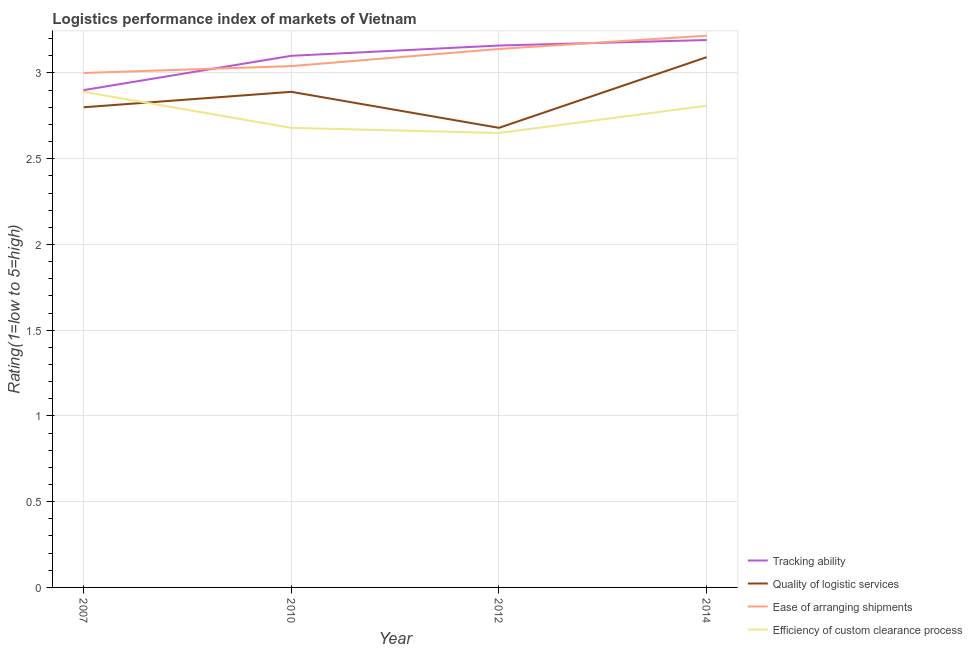What is the lpi rating of tracking ability in 2007?
Provide a succinct answer. 2.9. Across all years, what is the maximum lpi rating of tracking ability?
Offer a very short reply. 3.19. Across all years, what is the minimum lpi rating of quality of logistic services?
Offer a very short reply. 2.68. In which year was the lpi rating of quality of logistic services minimum?
Offer a terse response. 2012. What is the total lpi rating of efficiency of custom clearance process in the graph?
Your answer should be compact. 11.03. What is the difference between the lpi rating of tracking ability in 2012 and that in 2014?
Your response must be concise. -0.03. What is the difference between the lpi rating of efficiency of custom clearance process in 2014 and the lpi rating of tracking ability in 2012?
Provide a succinct answer. -0.35. What is the average lpi rating of quality of logistic services per year?
Your answer should be very brief. 2.87. In the year 2012, what is the difference between the lpi rating of quality of logistic services and lpi rating of ease of arranging shipments?
Ensure brevity in your answer.  -0.46. What is the ratio of the lpi rating of efficiency of custom clearance process in 2010 to that in 2012?
Offer a very short reply. 1.01. Is the lpi rating of efficiency of custom clearance process in 2007 less than that in 2014?
Your response must be concise. No. Is the difference between the lpi rating of tracking ability in 2007 and 2012 greater than the difference between the lpi rating of efficiency of custom clearance process in 2007 and 2012?
Ensure brevity in your answer.  No. What is the difference between the highest and the second highest lpi rating of ease of arranging shipments?
Make the answer very short. 0.08. What is the difference between the highest and the lowest lpi rating of quality of logistic services?
Your response must be concise. 0.41. Is it the case that in every year, the sum of the lpi rating of quality of logistic services and lpi rating of ease of arranging shipments is greater than the sum of lpi rating of efficiency of custom clearance process and lpi rating of tracking ability?
Your answer should be very brief. Yes. Is the lpi rating of tracking ability strictly greater than the lpi rating of efficiency of custom clearance process over the years?
Offer a terse response. Yes. How many years are there in the graph?
Provide a succinct answer. 4. What is the difference between two consecutive major ticks on the Y-axis?
Make the answer very short. 0.5. Are the values on the major ticks of Y-axis written in scientific E-notation?
Provide a short and direct response. No. Does the graph contain any zero values?
Your answer should be compact. No. Does the graph contain grids?
Make the answer very short. Yes. How are the legend labels stacked?
Offer a terse response. Vertical. What is the title of the graph?
Your response must be concise. Logistics performance index of markets of Vietnam. Does "Other expenses" appear as one of the legend labels in the graph?
Your answer should be compact. No. What is the label or title of the X-axis?
Offer a terse response. Year. What is the label or title of the Y-axis?
Make the answer very short. Rating(1=low to 5=high). What is the Rating(1=low to 5=high) of Quality of logistic services in 2007?
Ensure brevity in your answer.  2.8. What is the Rating(1=low to 5=high) of Ease of arranging shipments in 2007?
Provide a short and direct response. 3. What is the Rating(1=low to 5=high) of Efficiency of custom clearance process in 2007?
Your answer should be compact. 2.89. What is the Rating(1=low to 5=high) of Tracking ability in 2010?
Ensure brevity in your answer.  3.1. What is the Rating(1=low to 5=high) in Quality of logistic services in 2010?
Your answer should be compact. 2.89. What is the Rating(1=low to 5=high) in Ease of arranging shipments in 2010?
Keep it short and to the point. 3.04. What is the Rating(1=low to 5=high) of Efficiency of custom clearance process in 2010?
Your answer should be very brief. 2.68. What is the Rating(1=low to 5=high) in Tracking ability in 2012?
Your answer should be very brief. 3.16. What is the Rating(1=low to 5=high) of Quality of logistic services in 2012?
Your answer should be very brief. 2.68. What is the Rating(1=low to 5=high) of Ease of arranging shipments in 2012?
Offer a terse response. 3.14. What is the Rating(1=low to 5=high) of Efficiency of custom clearance process in 2012?
Keep it short and to the point. 2.65. What is the Rating(1=low to 5=high) in Tracking ability in 2014?
Give a very brief answer. 3.19. What is the Rating(1=low to 5=high) in Quality of logistic services in 2014?
Keep it short and to the point. 3.09. What is the Rating(1=low to 5=high) of Ease of arranging shipments in 2014?
Your response must be concise. 3.22. What is the Rating(1=low to 5=high) of Efficiency of custom clearance process in 2014?
Your answer should be compact. 2.81. Across all years, what is the maximum Rating(1=low to 5=high) of Tracking ability?
Offer a very short reply. 3.19. Across all years, what is the maximum Rating(1=low to 5=high) in Quality of logistic services?
Your answer should be very brief. 3.09. Across all years, what is the maximum Rating(1=low to 5=high) in Ease of arranging shipments?
Keep it short and to the point. 3.22. Across all years, what is the maximum Rating(1=low to 5=high) in Efficiency of custom clearance process?
Make the answer very short. 2.89. Across all years, what is the minimum Rating(1=low to 5=high) in Quality of logistic services?
Ensure brevity in your answer.  2.68. Across all years, what is the minimum Rating(1=low to 5=high) of Efficiency of custom clearance process?
Offer a terse response. 2.65. What is the total Rating(1=low to 5=high) in Tracking ability in the graph?
Make the answer very short. 12.35. What is the total Rating(1=low to 5=high) of Quality of logistic services in the graph?
Give a very brief answer. 11.46. What is the total Rating(1=low to 5=high) of Ease of arranging shipments in the graph?
Your response must be concise. 12.4. What is the total Rating(1=low to 5=high) of Efficiency of custom clearance process in the graph?
Your answer should be very brief. 11.03. What is the difference between the Rating(1=low to 5=high) of Quality of logistic services in 2007 and that in 2010?
Your response must be concise. -0.09. What is the difference between the Rating(1=low to 5=high) of Ease of arranging shipments in 2007 and that in 2010?
Ensure brevity in your answer.  -0.04. What is the difference between the Rating(1=low to 5=high) in Efficiency of custom clearance process in 2007 and that in 2010?
Provide a succinct answer. 0.21. What is the difference between the Rating(1=low to 5=high) in Tracking ability in 2007 and that in 2012?
Your answer should be compact. -0.26. What is the difference between the Rating(1=low to 5=high) in Quality of logistic services in 2007 and that in 2012?
Provide a succinct answer. 0.12. What is the difference between the Rating(1=low to 5=high) of Ease of arranging shipments in 2007 and that in 2012?
Offer a very short reply. -0.14. What is the difference between the Rating(1=low to 5=high) of Efficiency of custom clearance process in 2007 and that in 2012?
Keep it short and to the point. 0.24. What is the difference between the Rating(1=low to 5=high) in Tracking ability in 2007 and that in 2014?
Offer a terse response. -0.29. What is the difference between the Rating(1=low to 5=high) in Quality of logistic services in 2007 and that in 2014?
Offer a terse response. -0.29. What is the difference between the Rating(1=low to 5=high) in Ease of arranging shipments in 2007 and that in 2014?
Offer a terse response. -0.22. What is the difference between the Rating(1=low to 5=high) of Efficiency of custom clearance process in 2007 and that in 2014?
Your response must be concise. 0.08. What is the difference between the Rating(1=low to 5=high) in Tracking ability in 2010 and that in 2012?
Give a very brief answer. -0.06. What is the difference between the Rating(1=low to 5=high) in Quality of logistic services in 2010 and that in 2012?
Make the answer very short. 0.21. What is the difference between the Rating(1=low to 5=high) of Tracking ability in 2010 and that in 2014?
Keep it short and to the point. -0.09. What is the difference between the Rating(1=low to 5=high) in Quality of logistic services in 2010 and that in 2014?
Provide a succinct answer. -0.2. What is the difference between the Rating(1=low to 5=high) in Ease of arranging shipments in 2010 and that in 2014?
Give a very brief answer. -0.18. What is the difference between the Rating(1=low to 5=high) of Efficiency of custom clearance process in 2010 and that in 2014?
Make the answer very short. -0.13. What is the difference between the Rating(1=low to 5=high) in Tracking ability in 2012 and that in 2014?
Your response must be concise. -0.03. What is the difference between the Rating(1=low to 5=high) of Quality of logistic services in 2012 and that in 2014?
Your answer should be very brief. -0.41. What is the difference between the Rating(1=low to 5=high) of Ease of arranging shipments in 2012 and that in 2014?
Give a very brief answer. -0.08. What is the difference between the Rating(1=low to 5=high) of Efficiency of custom clearance process in 2012 and that in 2014?
Your answer should be compact. -0.16. What is the difference between the Rating(1=low to 5=high) in Tracking ability in 2007 and the Rating(1=low to 5=high) in Ease of arranging shipments in 2010?
Make the answer very short. -0.14. What is the difference between the Rating(1=low to 5=high) in Tracking ability in 2007 and the Rating(1=low to 5=high) in Efficiency of custom clearance process in 2010?
Keep it short and to the point. 0.22. What is the difference between the Rating(1=low to 5=high) in Quality of logistic services in 2007 and the Rating(1=low to 5=high) in Ease of arranging shipments in 2010?
Provide a succinct answer. -0.24. What is the difference between the Rating(1=low to 5=high) in Quality of logistic services in 2007 and the Rating(1=low to 5=high) in Efficiency of custom clearance process in 2010?
Provide a short and direct response. 0.12. What is the difference between the Rating(1=low to 5=high) of Ease of arranging shipments in 2007 and the Rating(1=low to 5=high) of Efficiency of custom clearance process in 2010?
Give a very brief answer. 0.32. What is the difference between the Rating(1=low to 5=high) in Tracking ability in 2007 and the Rating(1=low to 5=high) in Quality of logistic services in 2012?
Your answer should be compact. 0.22. What is the difference between the Rating(1=low to 5=high) of Tracking ability in 2007 and the Rating(1=low to 5=high) of Ease of arranging shipments in 2012?
Your answer should be very brief. -0.24. What is the difference between the Rating(1=low to 5=high) in Quality of logistic services in 2007 and the Rating(1=low to 5=high) in Ease of arranging shipments in 2012?
Keep it short and to the point. -0.34. What is the difference between the Rating(1=low to 5=high) of Ease of arranging shipments in 2007 and the Rating(1=low to 5=high) of Efficiency of custom clearance process in 2012?
Provide a short and direct response. 0.35. What is the difference between the Rating(1=low to 5=high) of Tracking ability in 2007 and the Rating(1=low to 5=high) of Quality of logistic services in 2014?
Make the answer very short. -0.19. What is the difference between the Rating(1=low to 5=high) in Tracking ability in 2007 and the Rating(1=low to 5=high) in Ease of arranging shipments in 2014?
Your answer should be compact. -0.32. What is the difference between the Rating(1=low to 5=high) of Tracking ability in 2007 and the Rating(1=low to 5=high) of Efficiency of custom clearance process in 2014?
Your answer should be very brief. 0.09. What is the difference between the Rating(1=low to 5=high) of Quality of logistic services in 2007 and the Rating(1=low to 5=high) of Ease of arranging shipments in 2014?
Give a very brief answer. -0.42. What is the difference between the Rating(1=low to 5=high) of Quality of logistic services in 2007 and the Rating(1=low to 5=high) of Efficiency of custom clearance process in 2014?
Offer a terse response. -0.01. What is the difference between the Rating(1=low to 5=high) of Ease of arranging shipments in 2007 and the Rating(1=low to 5=high) of Efficiency of custom clearance process in 2014?
Your response must be concise. 0.19. What is the difference between the Rating(1=low to 5=high) in Tracking ability in 2010 and the Rating(1=low to 5=high) in Quality of logistic services in 2012?
Your answer should be compact. 0.42. What is the difference between the Rating(1=low to 5=high) in Tracking ability in 2010 and the Rating(1=low to 5=high) in Ease of arranging shipments in 2012?
Your response must be concise. -0.04. What is the difference between the Rating(1=low to 5=high) of Tracking ability in 2010 and the Rating(1=low to 5=high) of Efficiency of custom clearance process in 2012?
Give a very brief answer. 0.45. What is the difference between the Rating(1=low to 5=high) in Quality of logistic services in 2010 and the Rating(1=low to 5=high) in Ease of arranging shipments in 2012?
Your answer should be very brief. -0.25. What is the difference between the Rating(1=low to 5=high) in Quality of logistic services in 2010 and the Rating(1=low to 5=high) in Efficiency of custom clearance process in 2012?
Offer a very short reply. 0.24. What is the difference between the Rating(1=low to 5=high) of Ease of arranging shipments in 2010 and the Rating(1=low to 5=high) of Efficiency of custom clearance process in 2012?
Provide a short and direct response. 0.39. What is the difference between the Rating(1=low to 5=high) in Tracking ability in 2010 and the Rating(1=low to 5=high) in Quality of logistic services in 2014?
Your answer should be very brief. 0.01. What is the difference between the Rating(1=low to 5=high) of Tracking ability in 2010 and the Rating(1=low to 5=high) of Ease of arranging shipments in 2014?
Make the answer very short. -0.12. What is the difference between the Rating(1=low to 5=high) in Tracking ability in 2010 and the Rating(1=low to 5=high) in Efficiency of custom clearance process in 2014?
Offer a terse response. 0.29. What is the difference between the Rating(1=low to 5=high) of Quality of logistic services in 2010 and the Rating(1=low to 5=high) of Ease of arranging shipments in 2014?
Make the answer very short. -0.33. What is the difference between the Rating(1=low to 5=high) of Quality of logistic services in 2010 and the Rating(1=low to 5=high) of Efficiency of custom clearance process in 2014?
Offer a terse response. 0.08. What is the difference between the Rating(1=low to 5=high) of Ease of arranging shipments in 2010 and the Rating(1=low to 5=high) of Efficiency of custom clearance process in 2014?
Provide a succinct answer. 0.23. What is the difference between the Rating(1=low to 5=high) of Tracking ability in 2012 and the Rating(1=low to 5=high) of Quality of logistic services in 2014?
Keep it short and to the point. 0.07. What is the difference between the Rating(1=low to 5=high) in Tracking ability in 2012 and the Rating(1=low to 5=high) in Ease of arranging shipments in 2014?
Keep it short and to the point. -0.06. What is the difference between the Rating(1=low to 5=high) of Tracking ability in 2012 and the Rating(1=low to 5=high) of Efficiency of custom clearance process in 2014?
Make the answer very short. 0.35. What is the difference between the Rating(1=low to 5=high) in Quality of logistic services in 2012 and the Rating(1=low to 5=high) in Ease of arranging shipments in 2014?
Ensure brevity in your answer.  -0.54. What is the difference between the Rating(1=low to 5=high) of Quality of logistic services in 2012 and the Rating(1=low to 5=high) of Efficiency of custom clearance process in 2014?
Ensure brevity in your answer.  -0.13. What is the difference between the Rating(1=low to 5=high) in Ease of arranging shipments in 2012 and the Rating(1=low to 5=high) in Efficiency of custom clearance process in 2014?
Your response must be concise. 0.33. What is the average Rating(1=low to 5=high) in Tracking ability per year?
Ensure brevity in your answer.  3.09. What is the average Rating(1=low to 5=high) in Quality of logistic services per year?
Provide a succinct answer. 2.87. What is the average Rating(1=low to 5=high) in Ease of arranging shipments per year?
Your answer should be very brief. 3.1. What is the average Rating(1=low to 5=high) of Efficiency of custom clearance process per year?
Your answer should be compact. 2.76. In the year 2007, what is the difference between the Rating(1=low to 5=high) of Tracking ability and Rating(1=low to 5=high) of Quality of logistic services?
Your answer should be compact. 0.1. In the year 2007, what is the difference between the Rating(1=low to 5=high) of Tracking ability and Rating(1=low to 5=high) of Ease of arranging shipments?
Provide a succinct answer. -0.1. In the year 2007, what is the difference between the Rating(1=low to 5=high) in Quality of logistic services and Rating(1=low to 5=high) in Ease of arranging shipments?
Offer a very short reply. -0.2. In the year 2007, what is the difference between the Rating(1=low to 5=high) in Quality of logistic services and Rating(1=low to 5=high) in Efficiency of custom clearance process?
Keep it short and to the point. -0.09. In the year 2007, what is the difference between the Rating(1=low to 5=high) of Ease of arranging shipments and Rating(1=low to 5=high) of Efficiency of custom clearance process?
Provide a succinct answer. 0.11. In the year 2010, what is the difference between the Rating(1=low to 5=high) of Tracking ability and Rating(1=low to 5=high) of Quality of logistic services?
Provide a succinct answer. 0.21. In the year 2010, what is the difference between the Rating(1=low to 5=high) in Tracking ability and Rating(1=low to 5=high) in Efficiency of custom clearance process?
Keep it short and to the point. 0.42. In the year 2010, what is the difference between the Rating(1=low to 5=high) of Quality of logistic services and Rating(1=low to 5=high) of Ease of arranging shipments?
Provide a succinct answer. -0.15. In the year 2010, what is the difference between the Rating(1=low to 5=high) of Quality of logistic services and Rating(1=low to 5=high) of Efficiency of custom clearance process?
Provide a short and direct response. 0.21. In the year 2010, what is the difference between the Rating(1=low to 5=high) in Ease of arranging shipments and Rating(1=low to 5=high) in Efficiency of custom clearance process?
Provide a succinct answer. 0.36. In the year 2012, what is the difference between the Rating(1=low to 5=high) in Tracking ability and Rating(1=low to 5=high) in Quality of logistic services?
Offer a terse response. 0.48. In the year 2012, what is the difference between the Rating(1=low to 5=high) of Tracking ability and Rating(1=low to 5=high) of Efficiency of custom clearance process?
Offer a very short reply. 0.51. In the year 2012, what is the difference between the Rating(1=low to 5=high) in Quality of logistic services and Rating(1=low to 5=high) in Ease of arranging shipments?
Provide a succinct answer. -0.46. In the year 2012, what is the difference between the Rating(1=low to 5=high) in Ease of arranging shipments and Rating(1=low to 5=high) in Efficiency of custom clearance process?
Ensure brevity in your answer.  0.49. In the year 2014, what is the difference between the Rating(1=low to 5=high) of Tracking ability and Rating(1=low to 5=high) of Quality of logistic services?
Give a very brief answer. 0.1. In the year 2014, what is the difference between the Rating(1=low to 5=high) of Tracking ability and Rating(1=low to 5=high) of Ease of arranging shipments?
Offer a terse response. -0.03. In the year 2014, what is the difference between the Rating(1=low to 5=high) in Tracking ability and Rating(1=low to 5=high) in Efficiency of custom clearance process?
Your answer should be very brief. 0.38. In the year 2014, what is the difference between the Rating(1=low to 5=high) of Quality of logistic services and Rating(1=low to 5=high) of Ease of arranging shipments?
Offer a terse response. -0.13. In the year 2014, what is the difference between the Rating(1=low to 5=high) of Quality of logistic services and Rating(1=low to 5=high) of Efficiency of custom clearance process?
Make the answer very short. 0.28. In the year 2014, what is the difference between the Rating(1=low to 5=high) of Ease of arranging shipments and Rating(1=low to 5=high) of Efficiency of custom clearance process?
Ensure brevity in your answer.  0.41. What is the ratio of the Rating(1=low to 5=high) of Tracking ability in 2007 to that in 2010?
Offer a terse response. 0.94. What is the ratio of the Rating(1=low to 5=high) in Quality of logistic services in 2007 to that in 2010?
Your response must be concise. 0.97. What is the ratio of the Rating(1=low to 5=high) of Efficiency of custom clearance process in 2007 to that in 2010?
Ensure brevity in your answer.  1.08. What is the ratio of the Rating(1=low to 5=high) of Tracking ability in 2007 to that in 2012?
Give a very brief answer. 0.92. What is the ratio of the Rating(1=low to 5=high) in Quality of logistic services in 2007 to that in 2012?
Offer a very short reply. 1.04. What is the ratio of the Rating(1=low to 5=high) of Ease of arranging shipments in 2007 to that in 2012?
Your answer should be compact. 0.96. What is the ratio of the Rating(1=low to 5=high) of Efficiency of custom clearance process in 2007 to that in 2012?
Your response must be concise. 1.09. What is the ratio of the Rating(1=low to 5=high) in Tracking ability in 2007 to that in 2014?
Offer a terse response. 0.91. What is the ratio of the Rating(1=low to 5=high) of Quality of logistic services in 2007 to that in 2014?
Make the answer very short. 0.91. What is the ratio of the Rating(1=low to 5=high) of Ease of arranging shipments in 2007 to that in 2014?
Make the answer very short. 0.93. What is the ratio of the Rating(1=low to 5=high) of Efficiency of custom clearance process in 2007 to that in 2014?
Keep it short and to the point. 1.03. What is the ratio of the Rating(1=low to 5=high) of Quality of logistic services in 2010 to that in 2012?
Provide a short and direct response. 1.08. What is the ratio of the Rating(1=low to 5=high) of Ease of arranging shipments in 2010 to that in 2012?
Give a very brief answer. 0.97. What is the ratio of the Rating(1=low to 5=high) of Efficiency of custom clearance process in 2010 to that in 2012?
Provide a succinct answer. 1.01. What is the ratio of the Rating(1=low to 5=high) in Tracking ability in 2010 to that in 2014?
Offer a terse response. 0.97. What is the ratio of the Rating(1=low to 5=high) of Quality of logistic services in 2010 to that in 2014?
Make the answer very short. 0.93. What is the ratio of the Rating(1=low to 5=high) in Ease of arranging shipments in 2010 to that in 2014?
Your answer should be very brief. 0.94. What is the ratio of the Rating(1=low to 5=high) in Efficiency of custom clearance process in 2010 to that in 2014?
Ensure brevity in your answer.  0.95. What is the ratio of the Rating(1=low to 5=high) in Tracking ability in 2012 to that in 2014?
Keep it short and to the point. 0.99. What is the ratio of the Rating(1=low to 5=high) in Quality of logistic services in 2012 to that in 2014?
Your answer should be very brief. 0.87. What is the ratio of the Rating(1=low to 5=high) in Ease of arranging shipments in 2012 to that in 2014?
Keep it short and to the point. 0.98. What is the ratio of the Rating(1=low to 5=high) in Efficiency of custom clearance process in 2012 to that in 2014?
Give a very brief answer. 0.94. What is the difference between the highest and the second highest Rating(1=low to 5=high) of Tracking ability?
Provide a short and direct response. 0.03. What is the difference between the highest and the second highest Rating(1=low to 5=high) in Quality of logistic services?
Your answer should be very brief. 0.2. What is the difference between the highest and the second highest Rating(1=low to 5=high) in Ease of arranging shipments?
Keep it short and to the point. 0.08. What is the difference between the highest and the second highest Rating(1=low to 5=high) of Efficiency of custom clearance process?
Your answer should be compact. 0.08. What is the difference between the highest and the lowest Rating(1=low to 5=high) of Tracking ability?
Ensure brevity in your answer.  0.29. What is the difference between the highest and the lowest Rating(1=low to 5=high) of Quality of logistic services?
Provide a succinct answer. 0.41. What is the difference between the highest and the lowest Rating(1=low to 5=high) in Ease of arranging shipments?
Ensure brevity in your answer.  0.22. What is the difference between the highest and the lowest Rating(1=low to 5=high) in Efficiency of custom clearance process?
Keep it short and to the point. 0.24. 